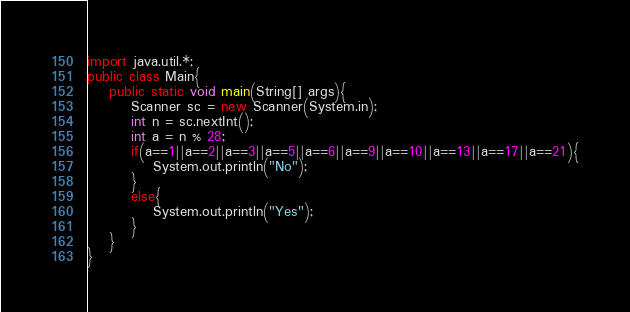<code> <loc_0><loc_0><loc_500><loc_500><_Java_>import java.util.*;
public class Main{
    public static void main(String[] args){
        Scanner sc = new Scanner(System.in);
        int n = sc.nextInt();
        int a = n % 28;
        if(a==1||a==2||a==3||a==5||a==6||a==9||a==10||a==13||a==17||a==21){
            System.out.println("No");
        }
        else{
            System.out.println("Yes");
        }
    }
}
</code> 